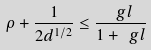<formula> <loc_0><loc_0><loc_500><loc_500>\rho + \frac { 1 } { 2 d ^ { 1 / 2 } } \leq \frac { \ g l } { 1 + \ g l }</formula> 